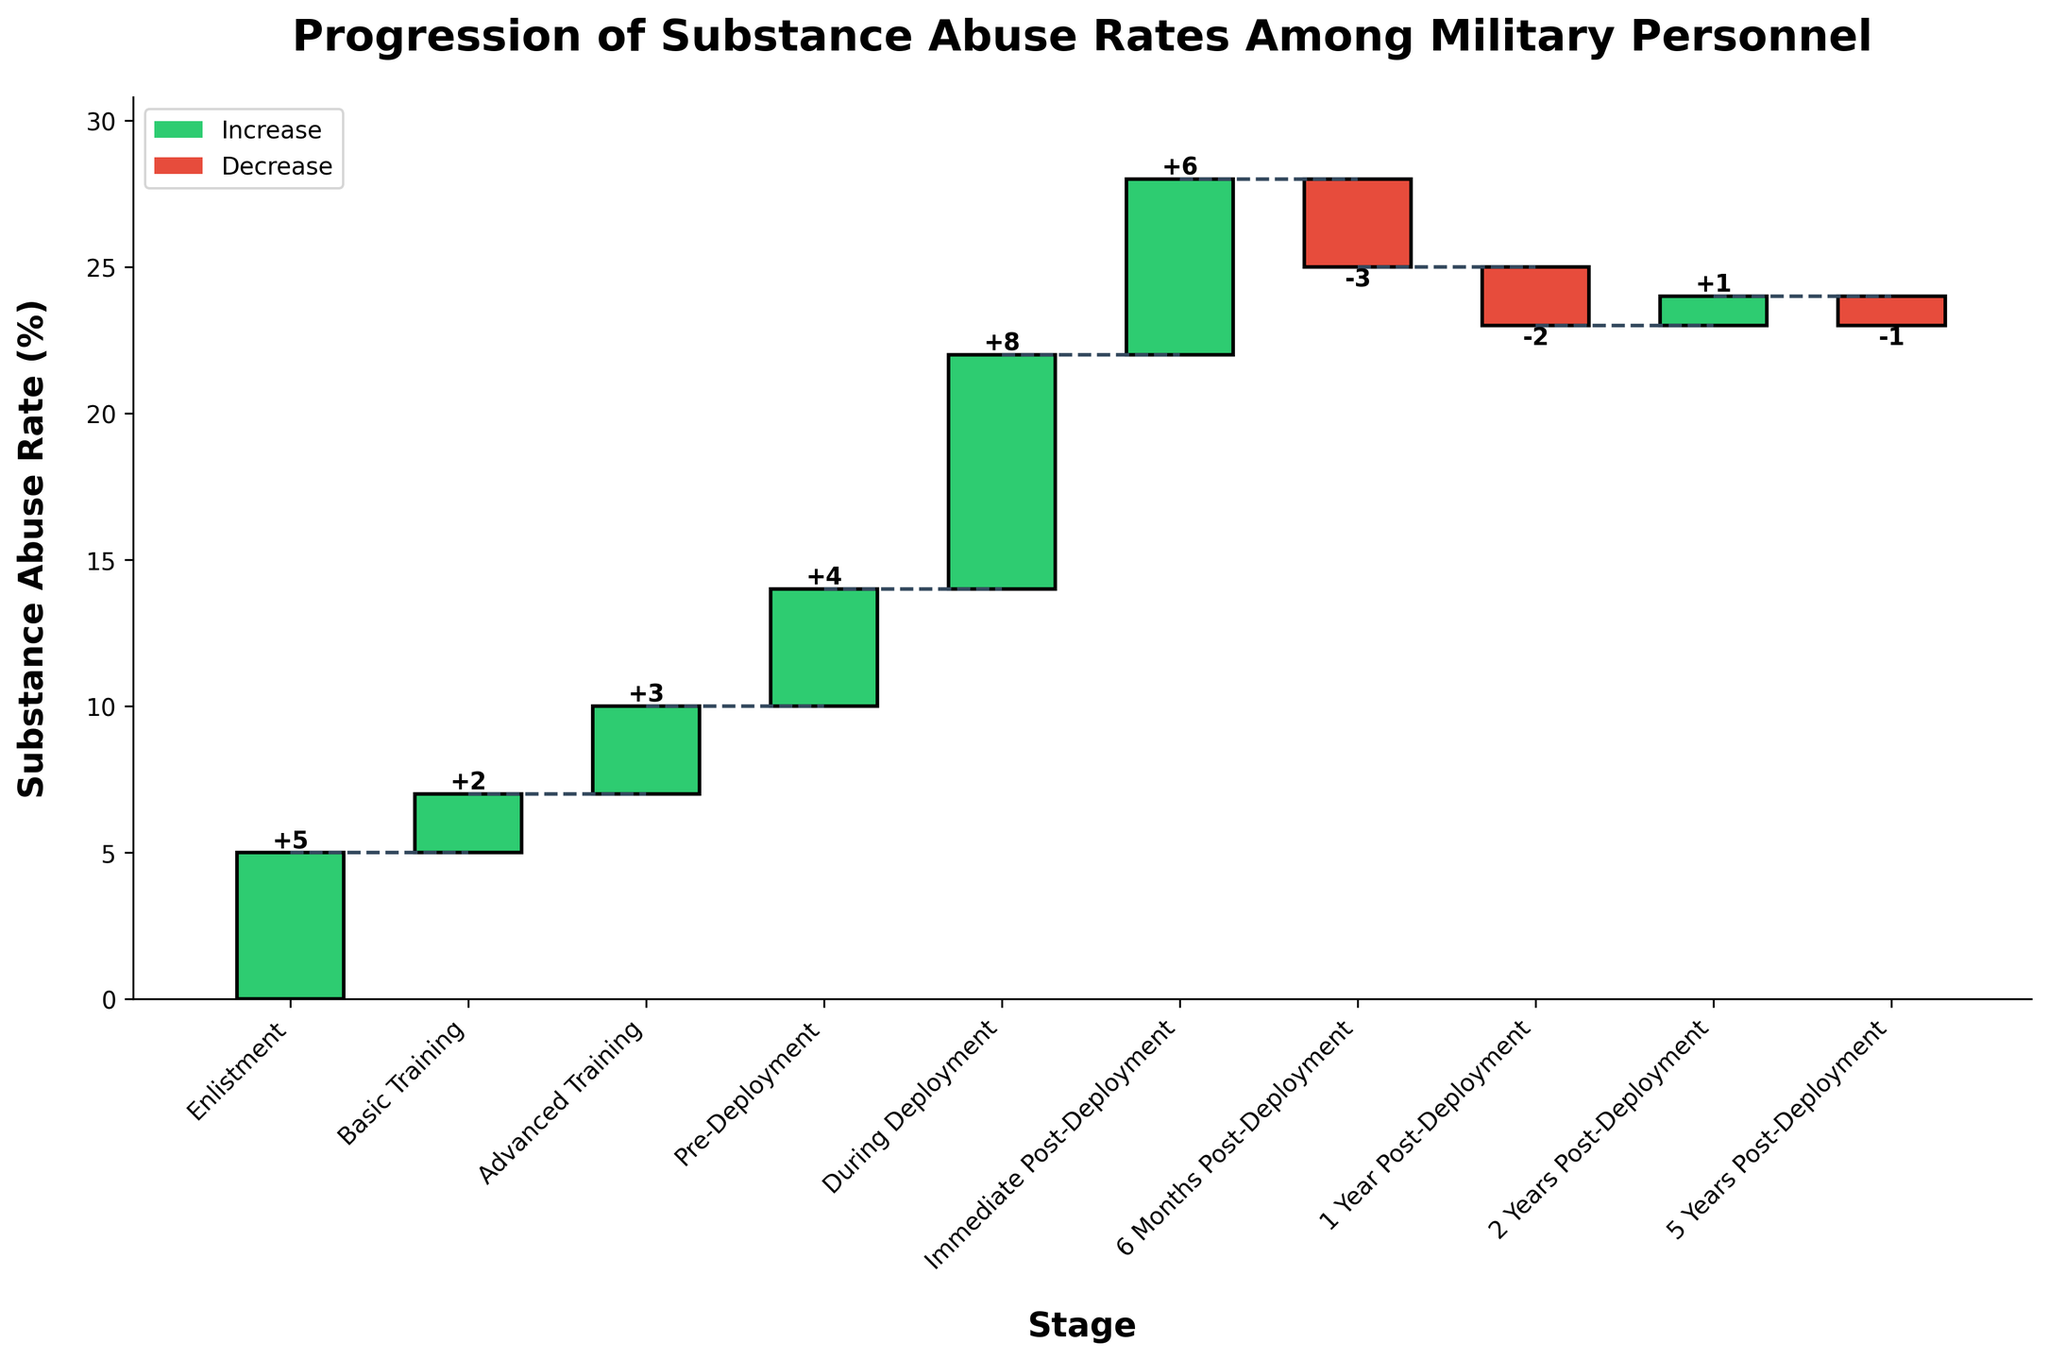What is the title of the figure? The title of the chart is located at the top and provides an overview of what the figure is about. In this case, it mentions "Progression of Substance Abuse Rates Among Military Personnel."
Answer: Progression of Substance Abuse Rates Among Military Personnel How many stages are shown in the chart? Count the number of stages displayed along the x-axis from "Enlistment" to "5 Years Post-Deployment".
Answer: 10 Which stage shows the highest increase in substance abuse rates? The stage with the highest positive bar represents the highest increase. Look for the tallest green bar.
Answer: During Deployment Which stages show a decrease in substance abuse rates? Identify the stages with red bars that indicate a decrease. These are the ones below the baseline.
Answer: 6 Months Post-Deployment, 1 Year Post-Deployment, 5 Years Post-Deployment What is the cumulative substance abuse rate during "Immediate Post-Deployment"? Locate "Immediate Post-Deployment" on the x-axis and refer to the height of the cumulative bar for this stage.
Answer: 28% By how much did the substance abuse rate change overall from enlistment to 5 years post-deployment? The overall change is the difference between the cumulative rate at the beginning (enlistment) and at the end (5 years post-deployment). Calculate the difference between the cumulative rates at these two points.
Answer: +18% Compare the substance abuse rate change between "During Deployment" and "Immediate Post-Deployment". Which one had a greater change? Compare the height of the bars for these two stages. The one with the taller positive bar had a greater increase.
Answer: During Deployment What is the cumulative substance abuse rate at 2 years post-deployment? Find the stage "2 Years Post-Deployment" on the x-axis and refer to the cumulative value.
Answer: 24% How did the substance abuse rates change after 1 year post-deployment? Look at the change in rates from "1 Year Post-Deployment" onward. Identify the stages, and note if there was an increase or decrease.
Answer: It increased by 1% at "2 Years Post-Deployment" and decreased by 1% at "5 Years Post-Deployment" Describe the trend in substance abuse rates from pre-deployment to 6 months post-deployment. Examine the change in values from "Pre-Deployment" through to "6 Months Post-Deployment." Sum up the changes in these stages to describe the overall trend.
Answer: Increased from 14% pre-deployment to 28% immediate post-deployment and then decreased to 25% at 6 months post-deployment 